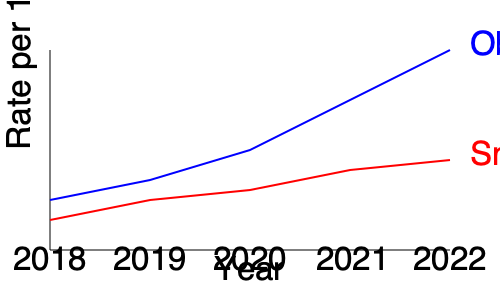Based on the line graph showing trends in obesity and smoking rates from 2018 to 2022, which public health indicator demonstrates a more significant change over the five-year period, and what does this suggest about the effectiveness of related health interventions? To answer this question, we need to analyze the trends for both obesity and smoking rates:

1. Obesity (blue line):
   - Starts at around 50 per 100,000 in 2018
   - Ends at about 200 per 100,000 in 2022
   - Shows a steep, consistent upward trend

2. Smoking (red line):
   - Starts at around 30 per 100,000 in 2018
   - Ends at about 90 per 100,000 in 2022
   - Shows a gradual, less steep upward trend

3. Comparing the changes:
   - Obesity increase: approximately 150 per 100,000
   - Smoking increase: approximately 60 per 100,000

4. Analyzing the significance:
   - Obesity shows a more dramatic increase over the five-year period
   - The change in obesity rates is more than twice that of smoking rates

5. Implications for health interventions:
   - The significant increase in obesity rates suggests that current interventions targeting obesity may be less effective or insufficient
   - The slower increase in smoking rates might indicate that anti-smoking campaigns and interventions are having some positive impact, though there's still an upward trend

Therefore, obesity demonstrates a more significant change over the five-year period. This suggests that health interventions targeting obesity may need to be reevaluated and strengthened, while smoking interventions, though not fully successful in reducing rates, may be having a moderating effect on the increase.
Answer: Obesity; suggests obesity interventions need strengthening, while smoking interventions may be moderately effective. 